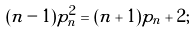<formula> <loc_0><loc_0><loc_500><loc_500>( n - 1 ) p _ { n } ^ { 2 } = ( n + 1 ) p _ { n } + 2 ;</formula> 